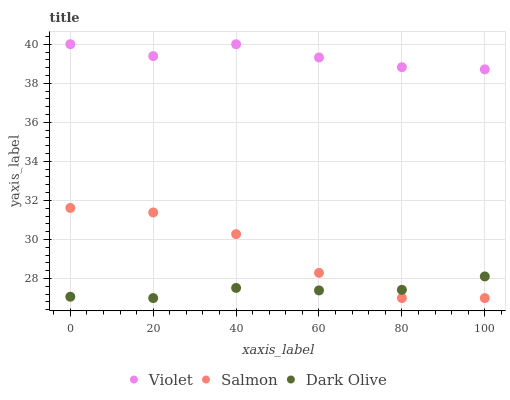Does Dark Olive have the minimum area under the curve?
Answer yes or no. Yes. Does Violet have the maximum area under the curve?
Answer yes or no. Yes. Does Salmon have the minimum area under the curve?
Answer yes or no. No. Does Salmon have the maximum area under the curve?
Answer yes or no. No. Is Dark Olive the smoothest?
Answer yes or no. Yes. Is Salmon the roughest?
Answer yes or no. Yes. Is Violet the smoothest?
Answer yes or no. No. Is Violet the roughest?
Answer yes or no. No. Does Dark Olive have the lowest value?
Answer yes or no. Yes. Does Violet have the lowest value?
Answer yes or no. No. Does Violet have the highest value?
Answer yes or no. Yes. Does Salmon have the highest value?
Answer yes or no. No. Is Salmon less than Violet?
Answer yes or no. Yes. Is Violet greater than Salmon?
Answer yes or no. Yes. Does Dark Olive intersect Salmon?
Answer yes or no. Yes. Is Dark Olive less than Salmon?
Answer yes or no. No. Is Dark Olive greater than Salmon?
Answer yes or no. No. Does Salmon intersect Violet?
Answer yes or no. No. 